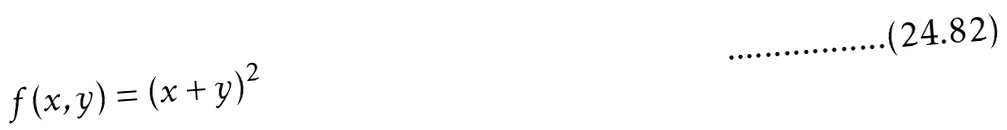Convert formula to latex. <formula><loc_0><loc_0><loc_500><loc_500>f ( x , y ) = ( x + y ) ^ { 2 }</formula> 